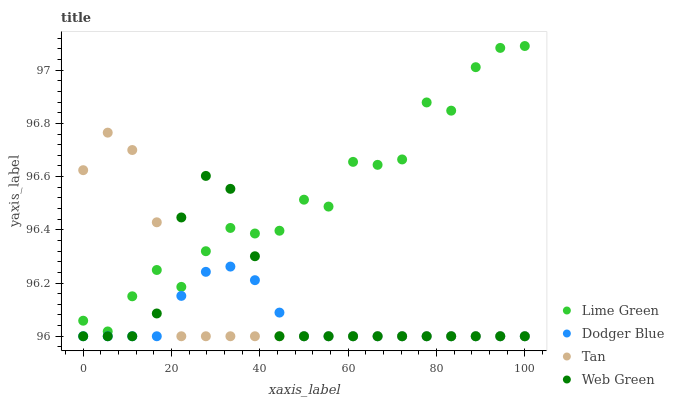Does Dodger Blue have the minimum area under the curve?
Answer yes or no. Yes. Does Lime Green have the maximum area under the curve?
Answer yes or no. Yes. Does Tan have the minimum area under the curve?
Answer yes or no. No. Does Tan have the maximum area under the curve?
Answer yes or no. No. Is Dodger Blue the smoothest?
Answer yes or no. Yes. Is Lime Green the roughest?
Answer yes or no. Yes. Is Tan the smoothest?
Answer yes or no. No. Is Tan the roughest?
Answer yes or no. No. Does Dodger Blue have the lowest value?
Answer yes or no. Yes. Does Lime Green have the lowest value?
Answer yes or no. No. Does Lime Green have the highest value?
Answer yes or no. Yes. Does Tan have the highest value?
Answer yes or no. No. Is Dodger Blue less than Lime Green?
Answer yes or no. Yes. Is Lime Green greater than Dodger Blue?
Answer yes or no. Yes. Does Web Green intersect Tan?
Answer yes or no. Yes. Is Web Green less than Tan?
Answer yes or no. No. Is Web Green greater than Tan?
Answer yes or no. No. Does Dodger Blue intersect Lime Green?
Answer yes or no. No. 